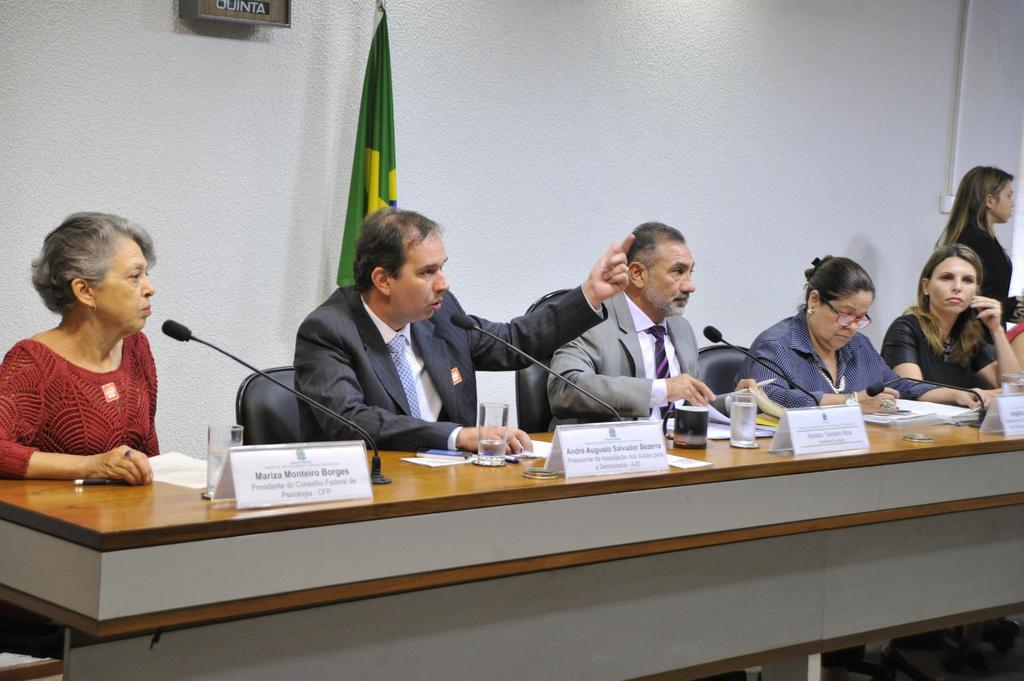In one or two sentences, can you explain what this image depicts? In this image there is a group of six person. Five of them are sitting on a chair and on the right one women is standing. Over here we can see a green color flag which is near to the white wall. On the table there is a water glass, name plates, mic and some papers. 